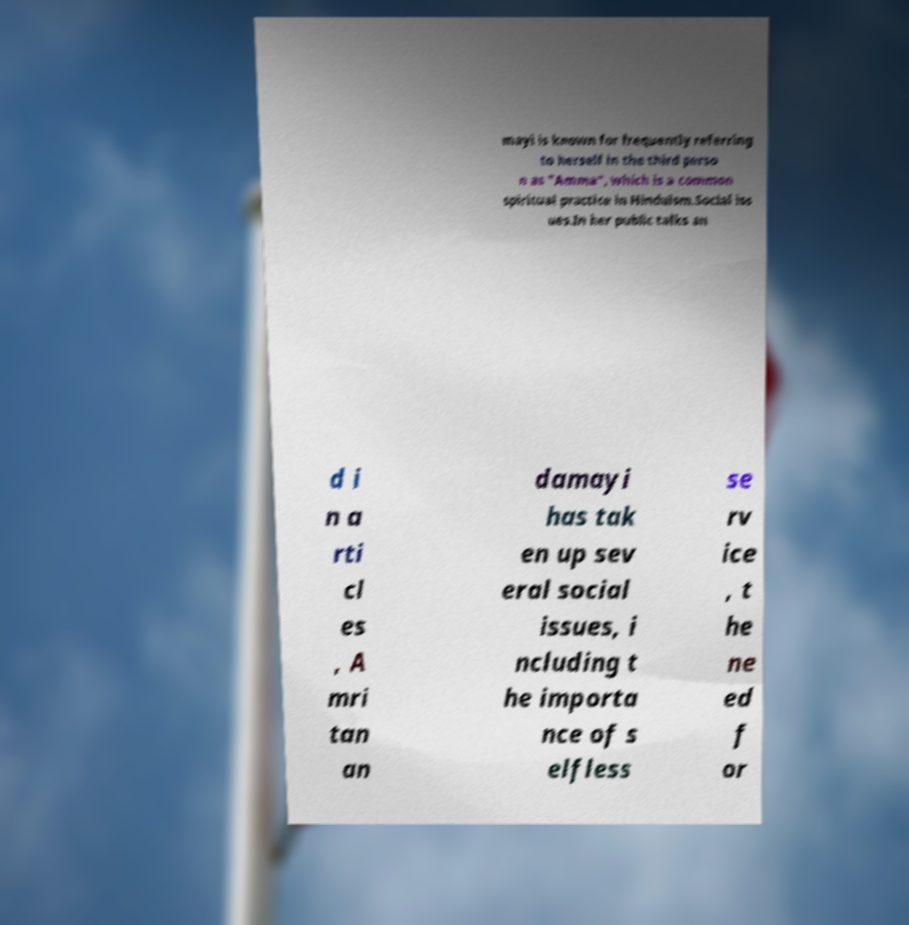There's text embedded in this image that I need extracted. Can you transcribe it verbatim? mayi is known for frequently referring to herself in the third perso n as "Amma", which is a common spiritual practice in Hinduism.Social iss ues.In her public talks an d i n a rti cl es , A mri tan an damayi has tak en up sev eral social issues, i ncluding t he importa nce of s elfless se rv ice , t he ne ed f or 